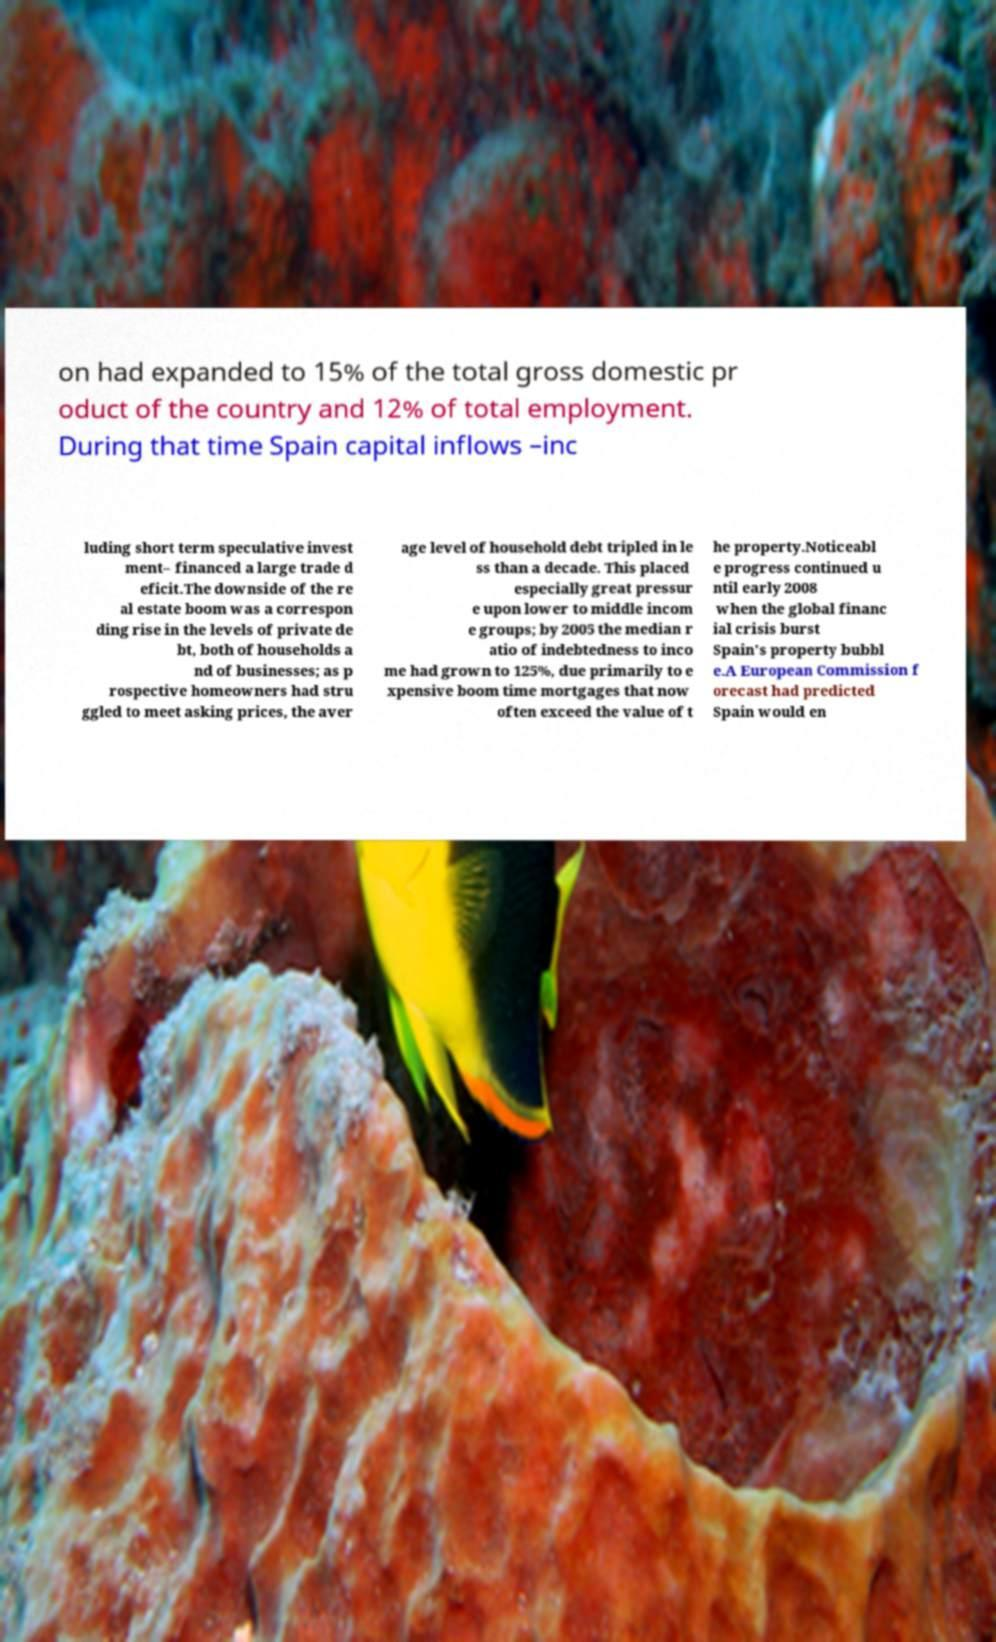Please read and relay the text visible in this image. What does it say? on had expanded to 15% of the total gross domestic pr oduct of the country and 12% of total employment. During that time Spain capital inflows –inc luding short term speculative invest ment– financed a large trade d eficit.The downside of the re al estate boom was a correspon ding rise in the levels of private de bt, both of households a nd of businesses; as p rospective homeowners had stru ggled to meet asking prices, the aver age level of household debt tripled in le ss than a decade. This placed especially great pressur e upon lower to middle incom e groups; by 2005 the median r atio of indebtedness to inco me had grown to 125%, due primarily to e xpensive boom time mortgages that now often exceed the value of t he property.Noticeabl e progress continued u ntil early 2008 when the global financ ial crisis burst Spain's property bubbl e.A European Commission f orecast had predicted Spain would en 